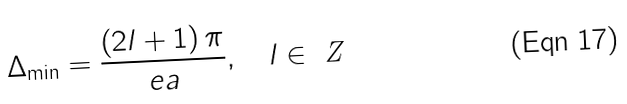Convert formula to latex. <formula><loc_0><loc_0><loc_500><loc_500>\Delta _ { \min } = \frac { \left ( 2 l + 1 \right ) \pi } { e a } , \quad l \in \emph { Z }</formula> 